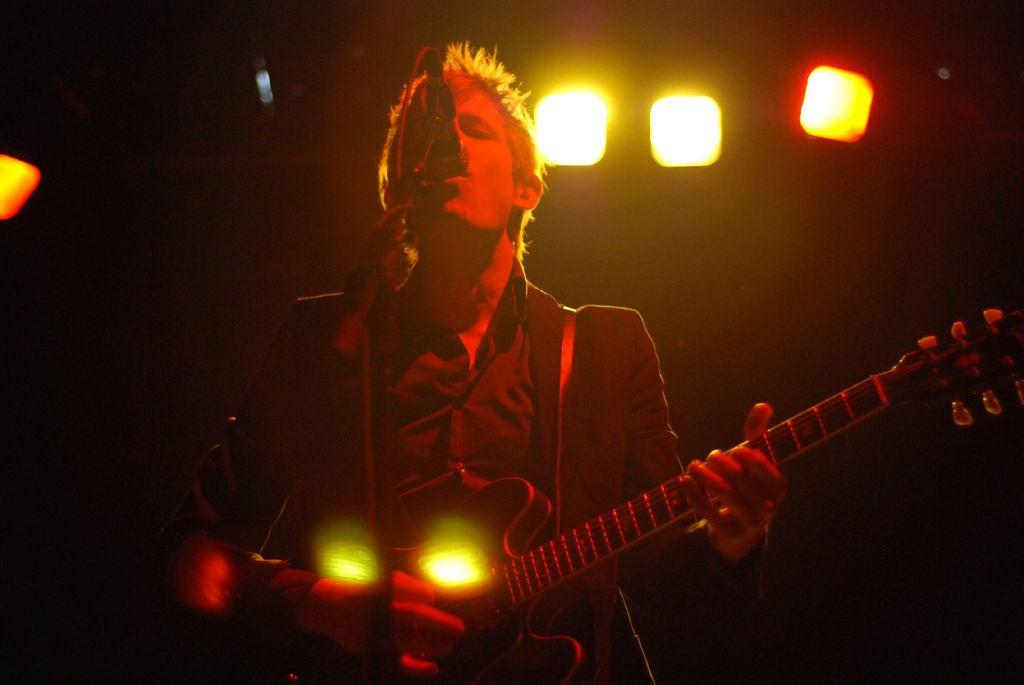What is the main subject of the image? There is a person in the image. What is the person doing in the image? The person is standing in the image. What object is the person holding in the image? The person is holding a guitar in his hand. What type of territory is being claimed by the hen in the image? There is no hen present in the image, so no territory is being claimed. 